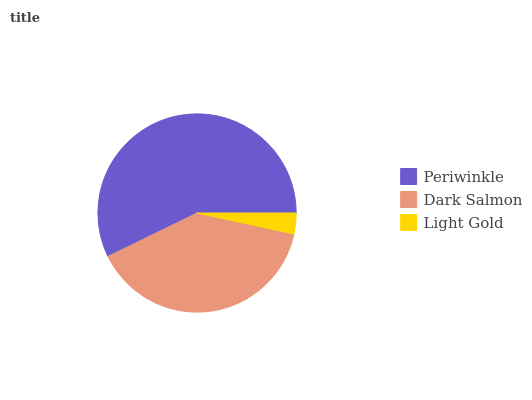Is Light Gold the minimum?
Answer yes or no. Yes. Is Periwinkle the maximum?
Answer yes or no. Yes. Is Dark Salmon the minimum?
Answer yes or no. No. Is Dark Salmon the maximum?
Answer yes or no. No. Is Periwinkle greater than Dark Salmon?
Answer yes or no. Yes. Is Dark Salmon less than Periwinkle?
Answer yes or no. Yes. Is Dark Salmon greater than Periwinkle?
Answer yes or no. No. Is Periwinkle less than Dark Salmon?
Answer yes or no. No. Is Dark Salmon the high median?
Answer yes or no. Yes. Is Dark Salmon the low median?
Answer yes or no. Yes. Is Light Gold the high median?
Answer yes or no. No. Is Periwinkle the low median?
Answer yes or no. No. 